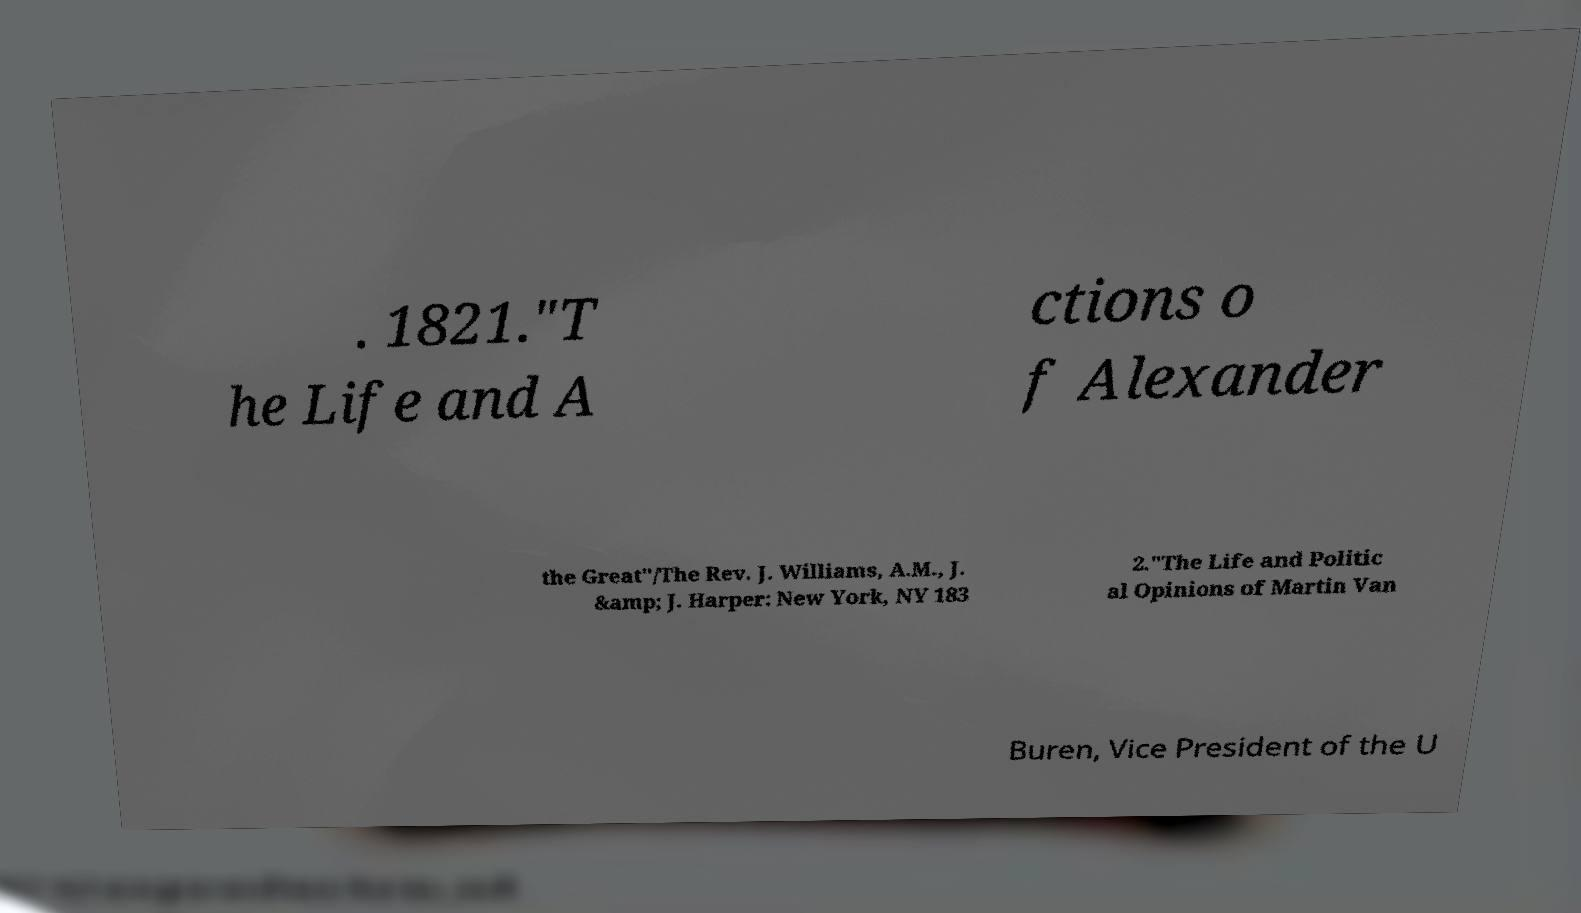Could you assist in decoding the text presented in this image and type it out clearly? . 1821."T he Life and A ctions o f Alexander the Great"/The Rev. J. Williams, A.M., J. &amp; J. Harper: New York, NY 183 2."The Life and Politic al Opinions of Martin Van Buren, Vice President of the U 